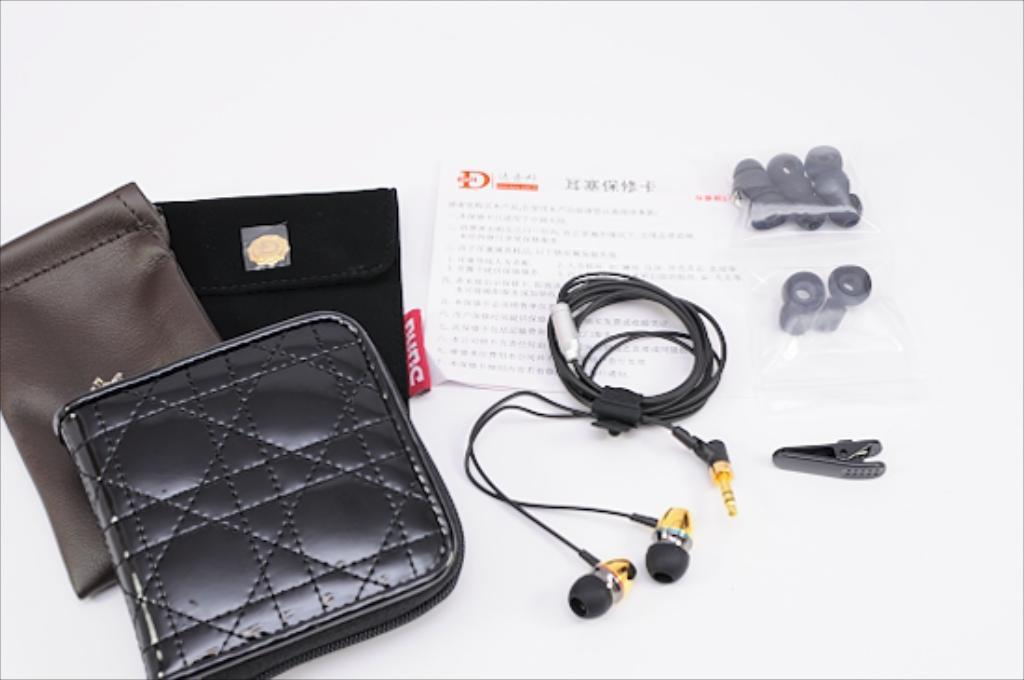What type of audio accessory is visible in the image? There are headphones and earbuds in the image. What other personal item can be seen in the image? There is a wallet in the image. What type of storage items are present in the image? There are pouches in the image. What material is used to cover the items in the image? The items are in polythene covers. What surface are the items placed on in the image? The items are placed on a table. What type of steam is being generated by the flesh in the image? There is no steam or flesh present in the image. What level of detail can be seen in the image? The image does not provide information about the level of detail, as it focuses on the items and their placement. 